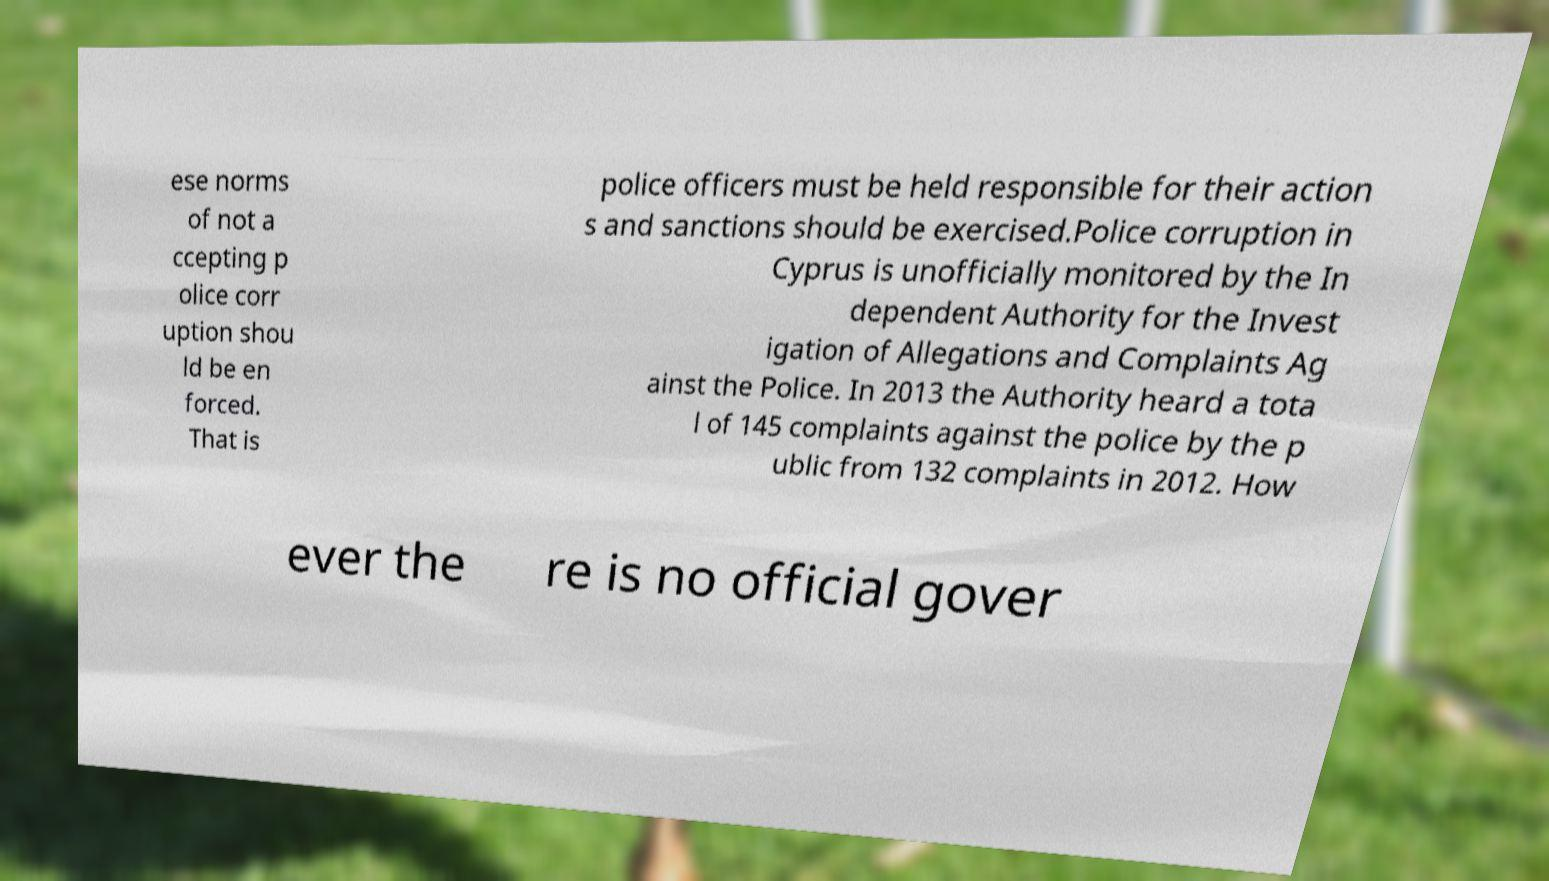For documentation purposes, I need the text within this image transcribed. Could you provide that? ese norms of not a ccepting p olice corr uption shou ld be en forced. That is police officers must be held responsible for their action s and sanctions should be exercised.Police corruption in Cyprus is unofficially monitored by the In dependent Authority for the Invest igation of Allegations and Complaints Ag ainst the Police. In 2013 the Authority heard a tota l of 145 complaints against the police by the p ublic from 132 complaints in 2012. How ever the re is no official gover 